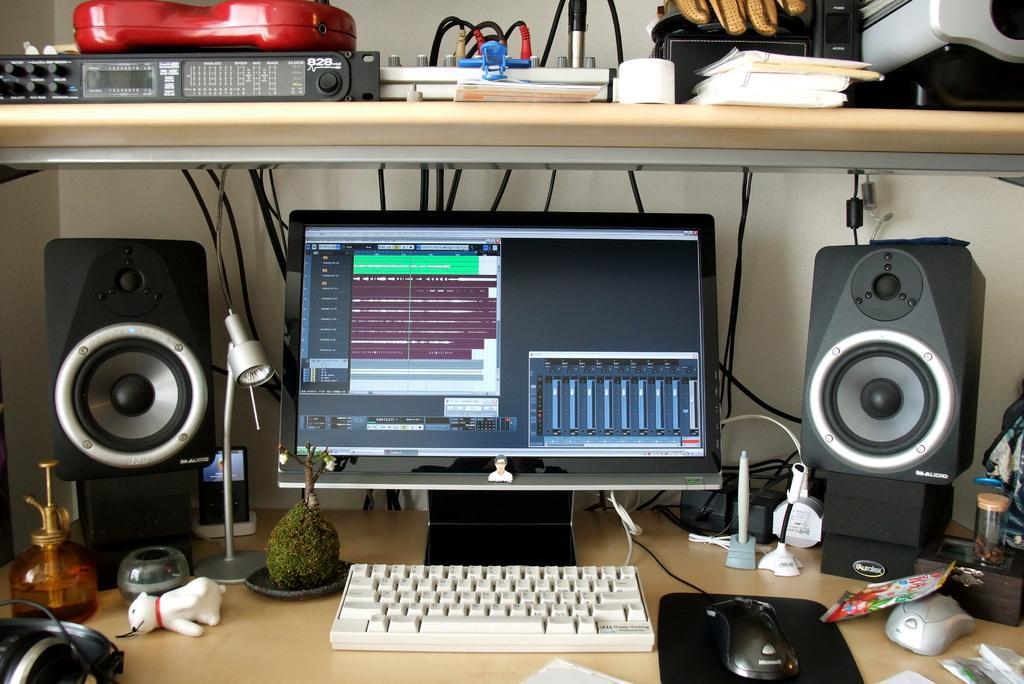Describe this image in one or two sentences. In this image there is a computer, speakers, lamp, plant, keyboard, mouse, mouse pad, wires, books, toy, head phones on the table. 